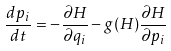Convert formula to latex. <formula><loc_0><loc_0><loc_500><loc_500>\frac { d p _ { i } } { d t } = - \frac { \partial H } { \partial q _ { i } } - g ( H ) \frac { \partial H } { \partial p _ { i } }</formula> 